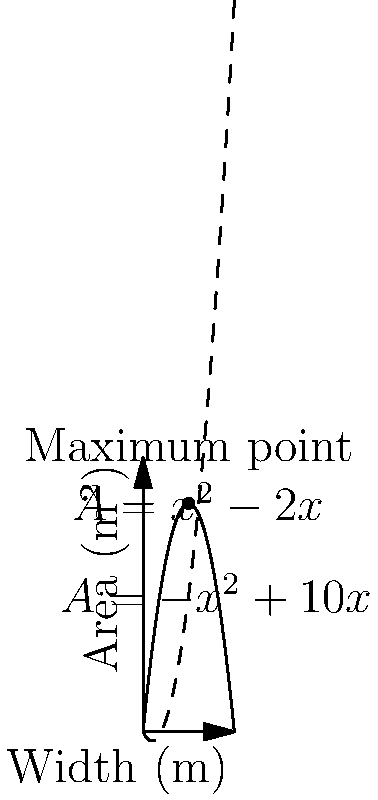As an animal rights advocate designing an optimal layout for a new animal shelter, you're tasked with maximizing the area of two connected enclosures. The total width of the shelter is fixed at 10 meters. Let $x$ represent the width of the first enclosure in meters. The area of the first enclosure is given by $A_1 = -x^2 + 10x$ square meters, while the area of the second enclosure is $A_2 = x^2 - 2x$ square meters. What width $x$ should be chosen to maximize the total area of both enclosures, and what is this maximum total area? Let's approach this step-by-step:

1) The total area $A$ is the sum of the areas of both enclosures:
   $A = A_1 + A_2 = (-x^2 + 10x) + (x^2 - 2x) = 8x$

2) This is a linear function, which means the maximum will occur at one of the endpoints of the domain.

3) The domain of $x$ is $[0, 10]$, as the width cannot be negative and cannot exceed the total width of 10 meters.

4) Let's evaluate $A$ at both endpoints:
   At $x = 0$: $A = 8(0) = 0$
   At $x = 10$: $A = 8(10) = 80$

5) Clearly, the maximum occurs when $x = 10$.

6) To verify, we can calculate the areas of each enclosure:
   $A_1 = -10^2 + 10(10) = 0$
   $A_2 = 10^2 - 2(10) = 80$

7) This makes sense in the context of the problem. The first enclosure's area function is a downward-facing parabola, while the second is an upward-facing parabola. The total area is maximized when we give all the space to the enclosure with the upward-facing parabola.

Therefore, the width should be chosen as 10 meters, giving all space to the second enclosure, for a maximum total area of 80 square meters.
Answer: $x = 10$ m, Maximum area = 80 m² 